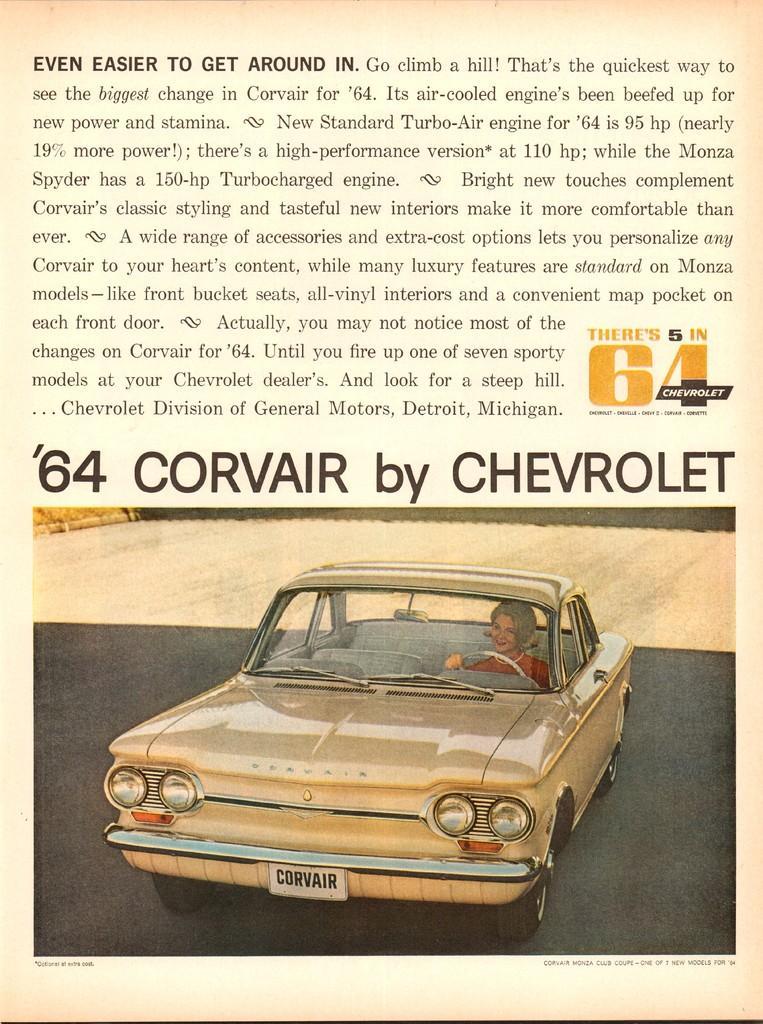Describe this image in one or two sentences. In this image there is an advertisement. 